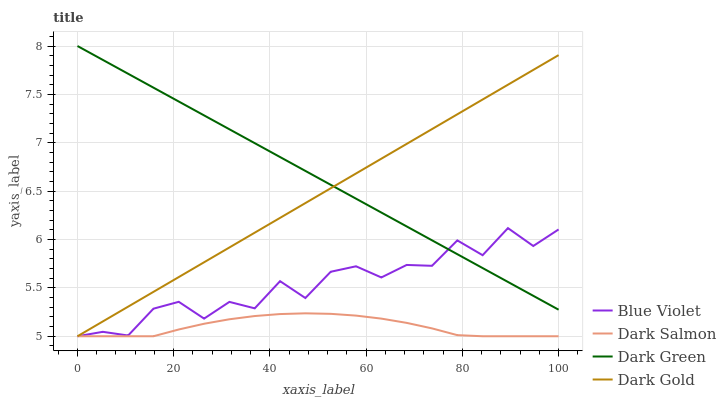Does Dark Salmon have the minimum area under the curve?
Answer yes or no. Yes. Does Dark Green have the maximum area under the curve?
Answer yes or no. Yes. Does Blue Violet have the minimum area under the curve?
Answer yes or no. No. Does Blue Violet have the maximum area under the curve?
Answer yes or no. No. Is Dark Gold the smoothest?
Answer yes or no. Yes. Is Blue Violet the roughest?
Answer yes or no. Yes. Is Dark Salmon the smoothest?
Answer yes or no. No. Is Dark Salmon the roughest?
Answer yes or no. No. Does Dark Gold have the lowest value?
Answer yes or no. Yes. Does Dark Green have the lowest value?
Answer yes or no. No. Does Dark Green have the highest value?
Answer yes or no. Yes. Does Blue Violet have the highest value?
Answer yes or no. No. Is Dark Salmon less than Dark Green?
Answer yes or no. Yes. Is Dark Green greater than Dark Salmon?
Answer yes or no. Yes. Does Dark Green intersect Dark Gold?
Answer yes or no. Yes. Is Dark Green less than Dark Gold?
Answer yes or no. No. Is Dark Green greater than Dark Gold?
Answer yes or no. No. Does Dark Salmon intersect Dark Green?
Answer yes or no. No. 